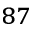Convert formula to latex. <formula><loc_0><loc_0><loc_500><loc_500>^ { 8 7 }</formula> 